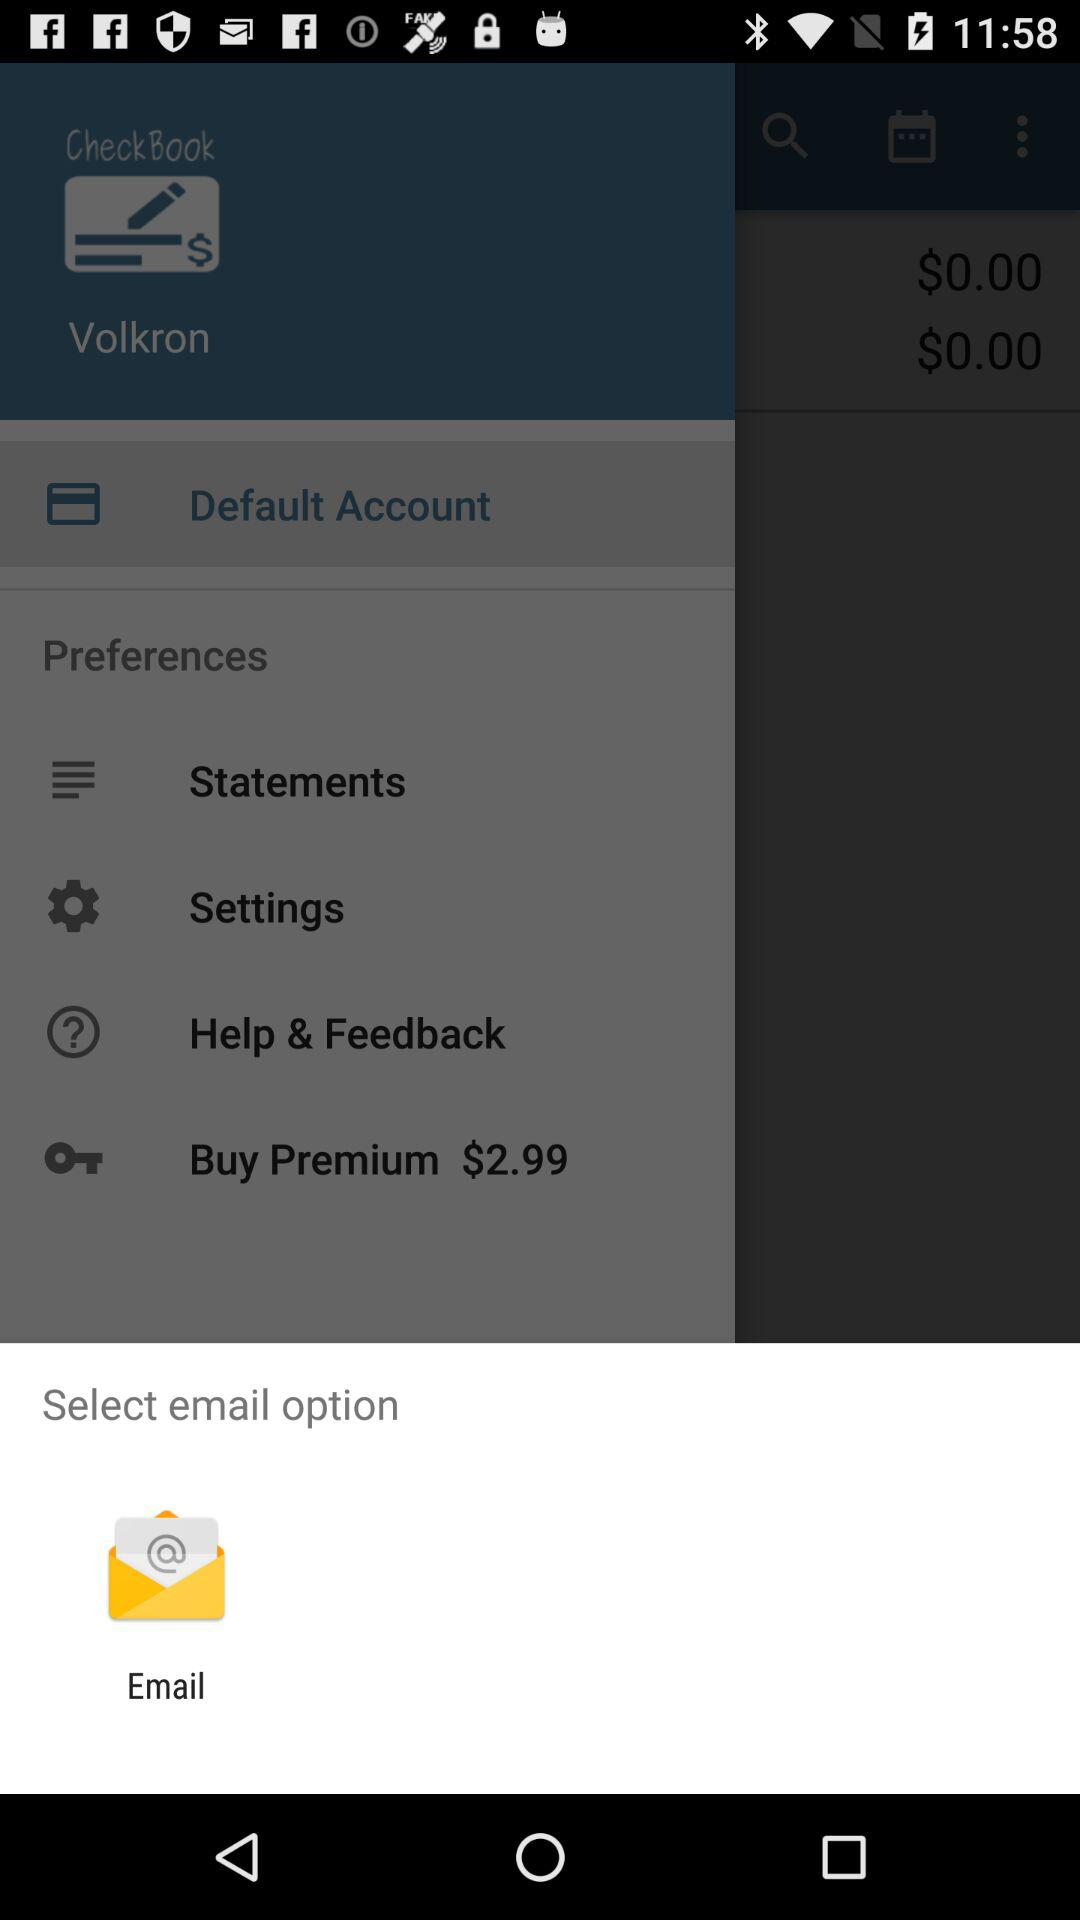What email option is available? The available email option is "Email". 